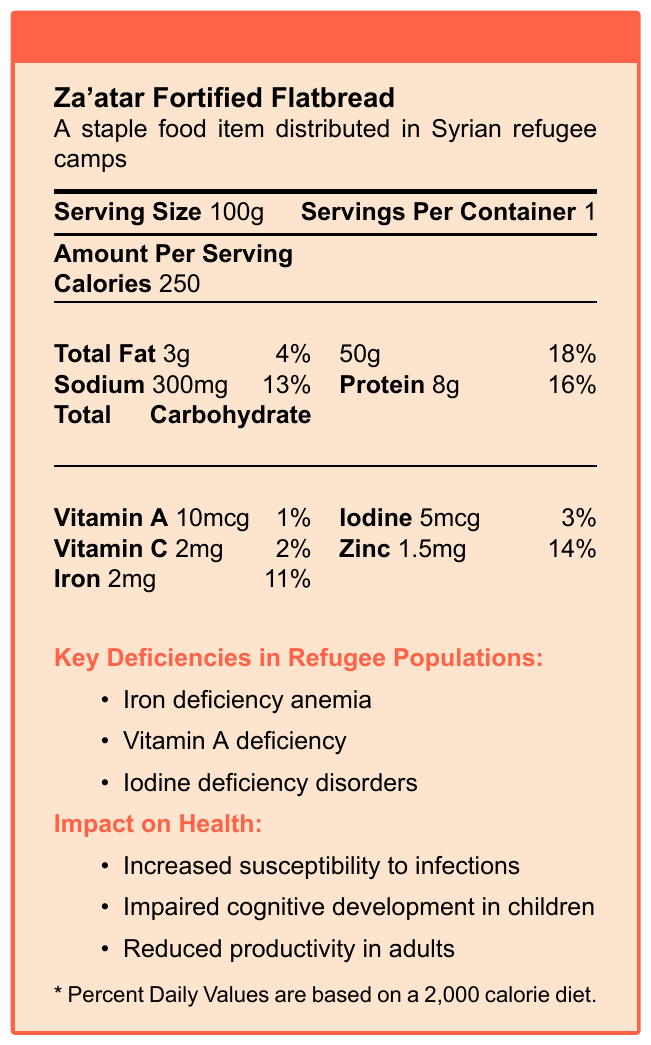what is the serving size of the Za'atar Fortified Flatbread? The document states that the serving size is 100g.
Answer: 100g how many calories are in one serving of the flatbread? The document specifies that there are 250 calories per serving.
Answer: 250 how much protein is in one serving of the flatbread? The document lists 8g of protein per serving.
Answer: 8g what percentage of the daily value is the total carbohydrate content? The document mentions that the total carbohydrate content is 50g, which represents 18% of the daily value.
Answer: 18% what are the key micronutrient deficiencies highlighted in the document? The document under "Key Deficiencies in Refugee Populations" lists these three deficiencies.
Answer: Iron deficiency anemia, Vitamin A deficiency, Iodine deficiency disorders which nutrient has the highest daily value percentage in the flatbread? A. Vitamin A B. Iron C. Zinc Zinc has a daily value percentage of 14%, which is the highest among the listed nutrients.
Answer: C what is the amount of sodium per serving? A. 100mg B. 200mg C. 300mg D. 400mg The document specifies that the sodium content per serving is 300mg.
Answer: C are there more than 5g of total fat in a serving? The document states that the total fat per serving is 3g, which is less than 5g.
Answer: No summarize the main idea of the document. This summary covers the document's primary content about nutritional values, deficiencies, health impacts, and relevant contextual information.
Answer: The document provides the nutritional information of Za'atar Fortified Flatbread, a staple food item distributed in Syrian refugee camps, highlighting the serving size, calories, macronutrient and micronutrient content, key micronutrient deficiencies, and their health impacts on the refugee population. how does iodine deficiency impact health according to the document? The document lists iodine deficiency disorders and impaired cognitive development as impacts of iodine deficiency.
Answer: Iodine deficiency can lead to iodine deficiency disorders, which impact cognitive development in children and productivity in adults. can the specific nutritional needs for each age group be found in the document? The document does not provide specific information about nutritional needs for different age groups.
Answer: Not enough information which micronutrient in the flatbread has the least percentage of daily value? The document shows that Vitamin A has the lowest daily value at 1%.
Answer: Vitamin A list the organizations involved in the refugee nutrition efforts according to the document. The document lists these organizations under "relevantOrganizations".
Answer: World Food Programme (WFP), UNHCR, Médecins Sans Frontières (MSF) what are the challenges in the distribution of this fortified flatbread? The document under "challengesInDistribution" outlines these challenges.
Answer: Limited cold storage facilities, inconsistent supply chains, cultural food preferences 